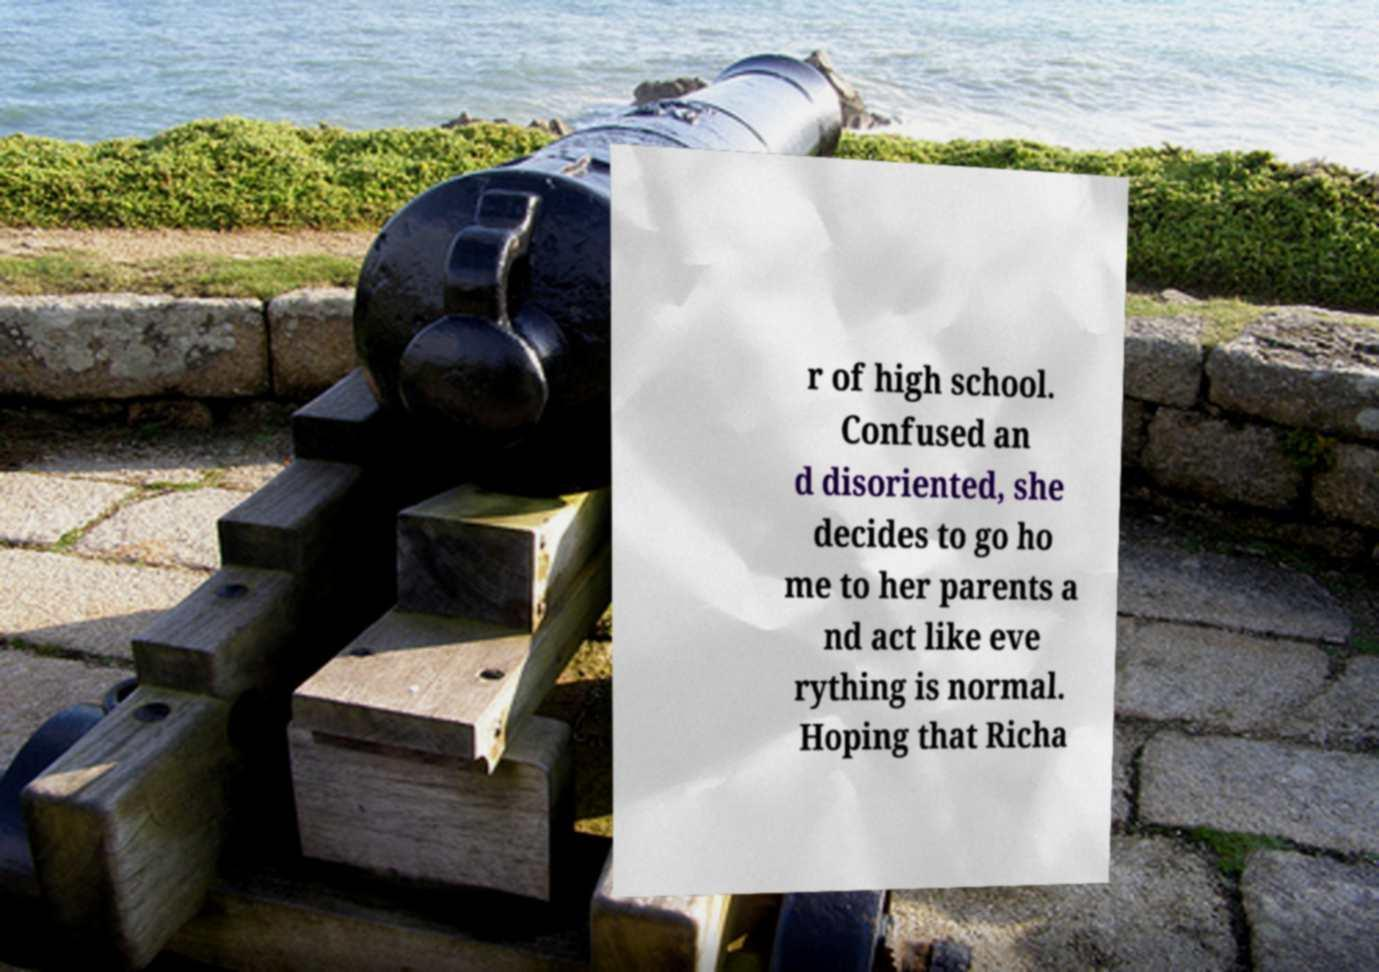I need the written content from this picture converted into text. Can you do that? r of high school. Confused an d disoriented, she decides to go ho me to her parents a nd act like eve rything is normal. Hoping that Richa 